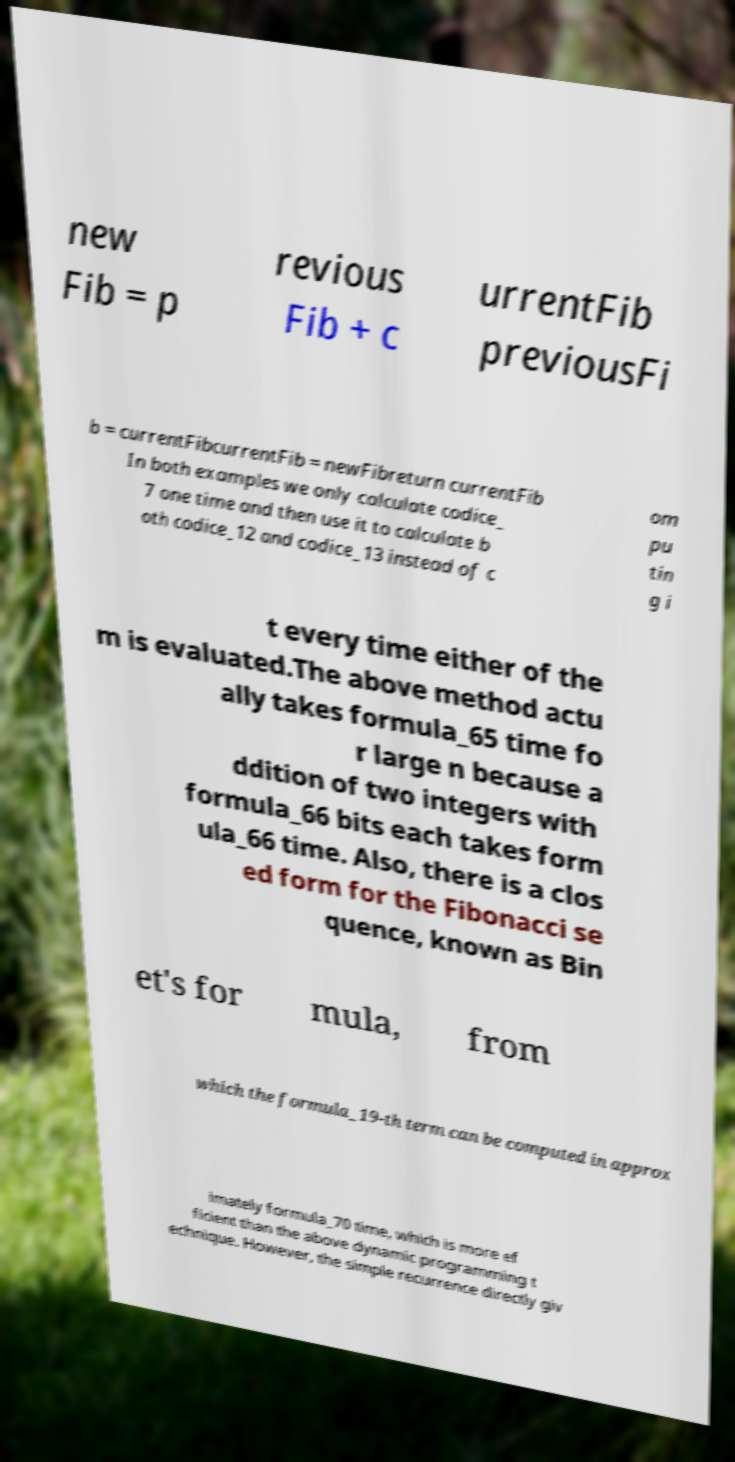Could you assist in decoding the text presented in this image and type it out clearly? new Fib = p revious Fib + c urrentFib previousFi b = currentFibcurrentFib = newFibreturn currentFib In both examples we only calculate codice_ 7 one time and then use it to calculate b oth codice_12 and codice_13 instead of c om pu tin g i t every time either of the m is evaluated.The above method actu ally takes formula_65 time fo r large n because a ddition of two integers with formula_66 bits each takes form ula_66 time. Also, there is a clos ed form for the Fibonacci se quence, known as Bin et's for mula, from which the formula_19-th term can be computed in approx imately formula_70 time, which is more ef ficient than the above dynamic programming t echnique. However, the simple recurrence directly giv 